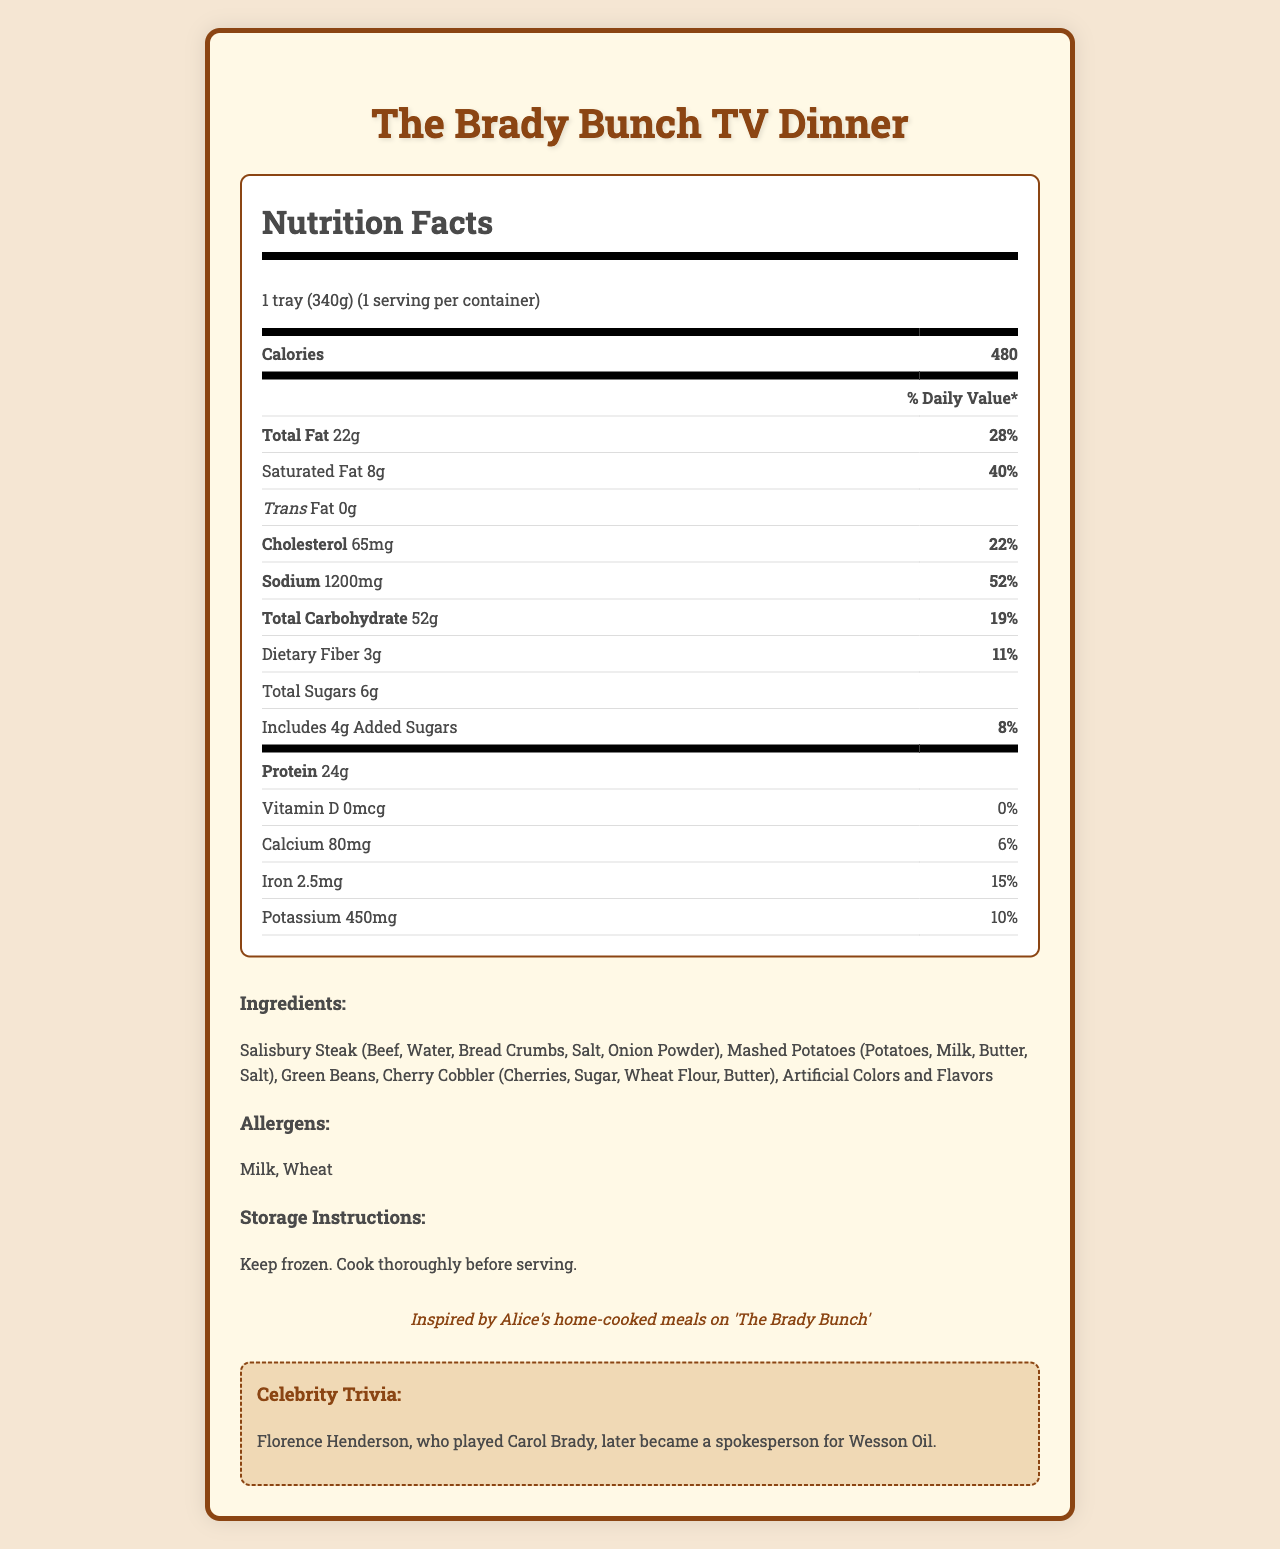what is the serving size? The serving size listed in the document is "1 tray (340g)."
Answer: 1 tray (340g) how many calories are in one serving? The document lists 480 calories per serving.
Answer: 480 calories what is the daily value percentage of sodium? The sodium amount has a daily value percentage of 52%.
Answer: 52% how many grams of protein does this TV dinner contain? The protein content is listed as 24g per serving.
Answer: 24g what allergens are present in this TV dinner? The document lists Milk and Wheat as allergens.
Answer: Milk, Wheat what type of meal is "The Brady Bunch TV Dinner" inspired by? A. The Andy Griffith Show B. The Brady Bunch C. Happy Days D. M*A*S*H The product name itself is "The Brady Bunch TV Dinner," indicating it is inspired by "The Brady Bunch."
Answer: B which nutrient has the highest daily value percentage? A. Saturated Fat B. Cholesterol C. Sodium D. Total Carbohydrate Sodium has the highest daily value percentage listed at 52%.
Answer: C does this TV dinner contain any artificial colors or flavors? The ingredients list includes "Artificial Colors and Flavors."
Answer: Yes was Florence Henderson, who played Carol Brady, a spokesperson for any product? The document mentions that Florence Henderson later became a spokesperson for Wesson Oil.
Answer: Yes what's one nostalgic note mentioned about this TV dinner? The document includes a note stating, "Inspired by Alice's home-cooked meals on 'The Brady Bunch.'"
Answer: Inspired by Alice's home-cooked meals on 'The Brady Bunch' how much added sugar is in this meal? The added sugar content is listed as 4g.
Answer: 4g describe what is included in "The Brady Bunch TV Dinner" nutrition facts label. The answer includes the product's name, serving size, calorie content, various nutrient amounts and daily values, ingredients, allergens, and additional notes provided in the document.
Answer: This TV dinner includes nutrition facts for a serving size of 1 tray (340g) and 480 calories per serving. It outlines the amounts and daily value percentages for total fat, saturated fat, trans fat, cholesterol, sodium, total carbohydrate, dietary fiber, total sugars, added sugars, protein, vitamin D, calcium, iron, and potassium. The ingredients are Salisbury Steak, Mashed Potatoes, Green Beans, Cherry Cobbler, and Artificial Colors and Flavors, with Milk and Wheat as allergens. There are storage instructions, a nostalgic note, and celebrity trivia included. how many grams of dietary fiber does this meal contain? The dietary fiber content is listed as 3g.
Answer: 3g is the vitamin D amount significant in this TV dinner? The document shows that the vitamin D content is 0mcg, which equals 0% of the daily value.
Answer: No why was this TV dinner named 'The Brady Bunch TV Dinner'? The document does not provide specific information on why this particular name was chosen beyond its nostalgic reference.
Answer: Not enough information how much calcium does this TV dinner provide? The document lists the calcium content as 80mg.
Answer: 80mg what are the storage instructions for this TV dinner? The storage instructions are "Keep frozen. Cook thoroughly before serving."
Answer: Keep frozen. Cook thoroughly before serving. 